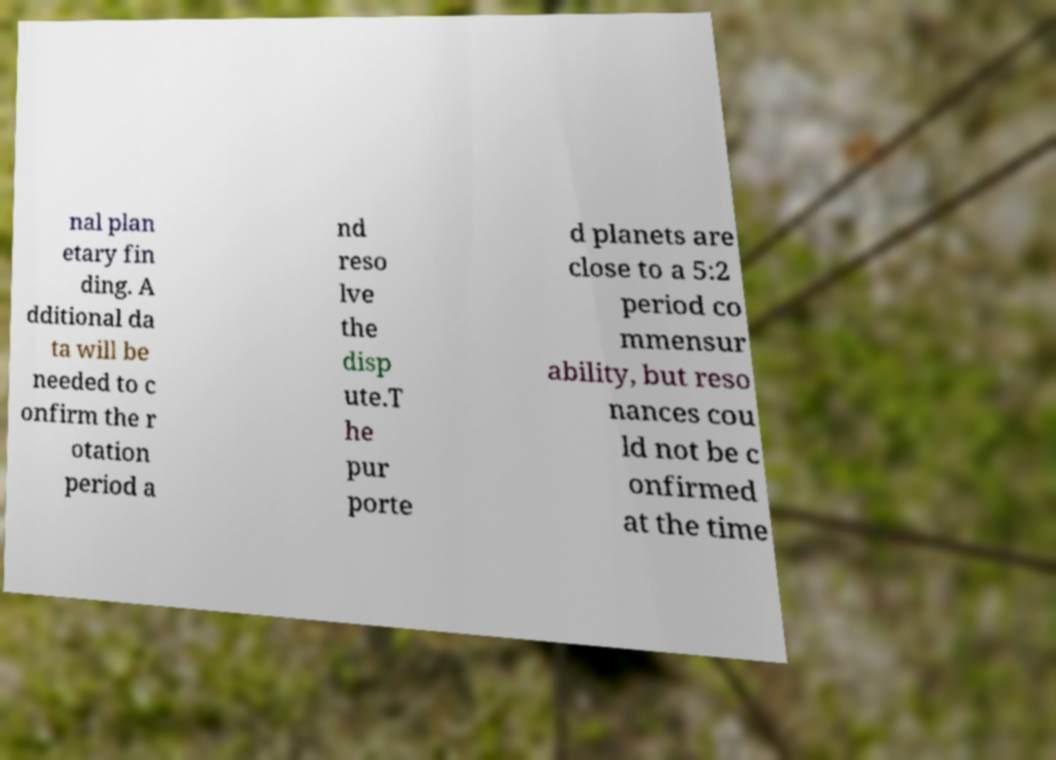Can you accurately transcribe the text from the provided image for me? nal plan etary fin ding. A dditional da ta will be needed to c onfirm the r otation period a nd reso lve the disp ute.T he pur porte d planets are close to a 5:2 period co mmensur ability, but reso nances cou ld not be c onfirmed at the time 